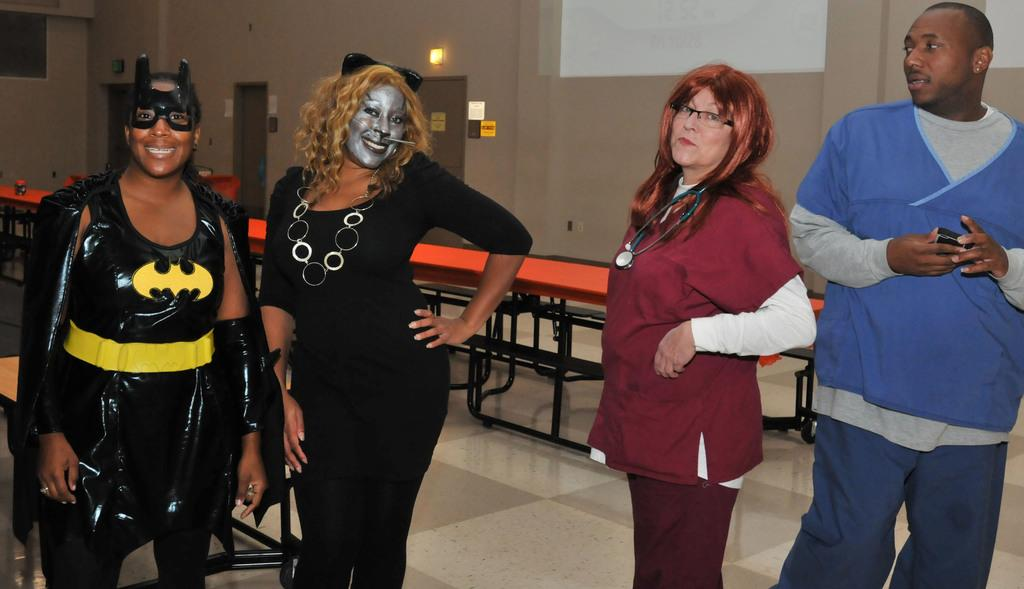How many people are in the image? There are four persons in the image. What are the persons wearing? The persons are wearing clothes. What is behind the persons in the image? The persons are standing in front of a wall. What object can be seen in the middle of the image? There is a table in the middle of the image. Can you tell me how many hills are visible in the image? There are no hills visible in the image; it features four persons standing in front of a wall with a table in the middle. What type of secretary is sitting at the table in the image? There is no secretary present in the image; it only shows four persons standing in front of a wall with a table in the middle. 